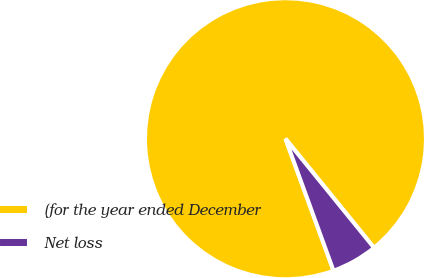Convert chart to OTSL. <chart><loc_0><loc_0><loc_500><loc_500><pie_chart><fcel>(for the year ended December<fcel>Net loss<nl><fcel>94.7%<fcel>5.3%<nl></chart> 